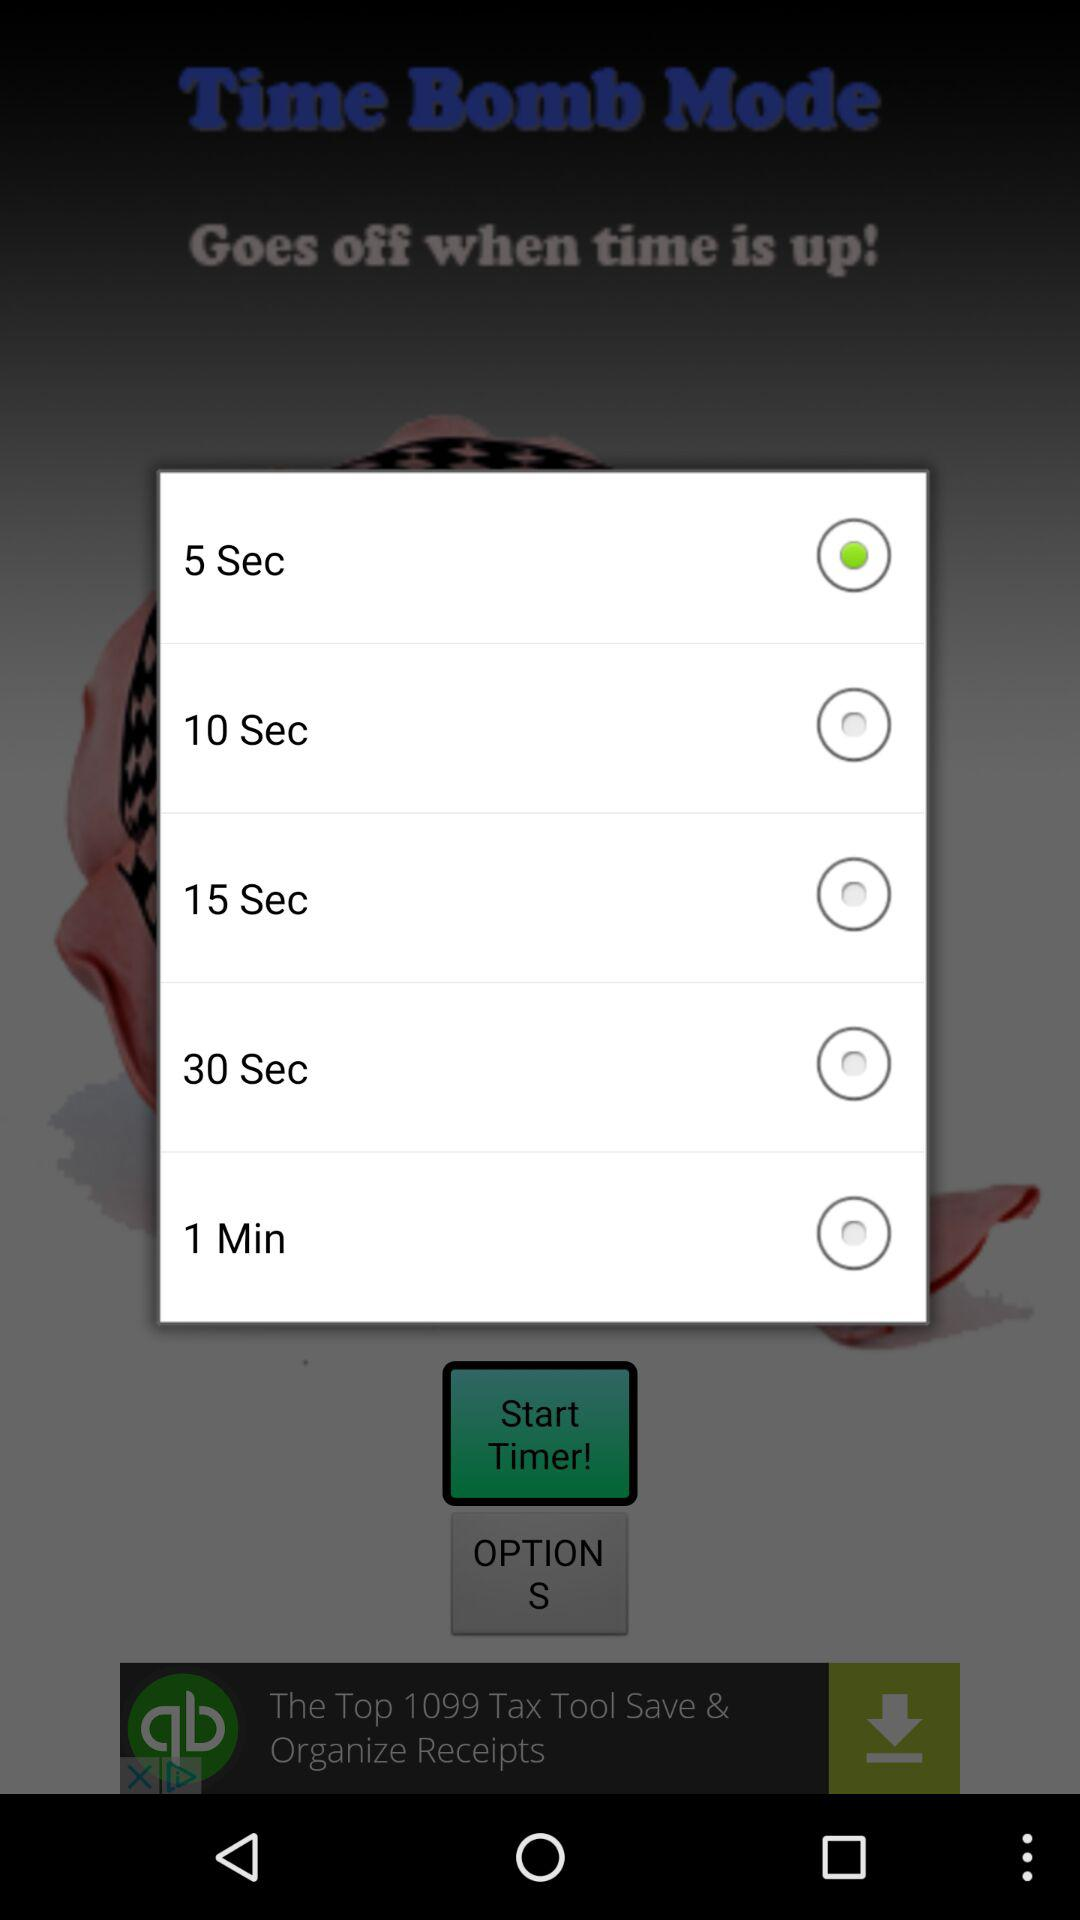How many seconds are there in the longest duration option?
Answer the question using a single word or phrase. 60 